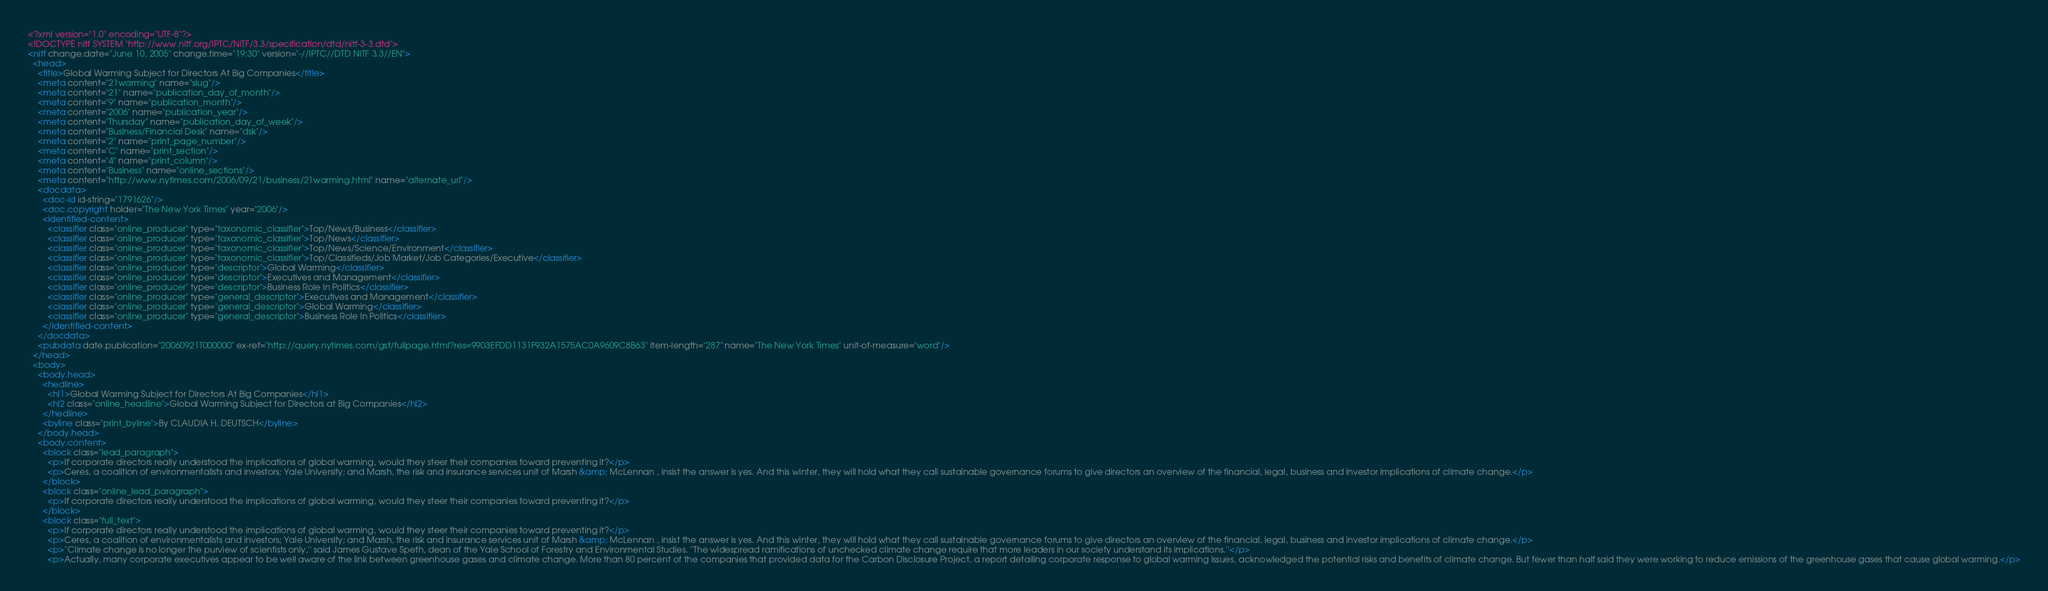<code> <loc_0><loc_0><loc_500><loc_500><_XML_><?xml version="1.0" encoding="UTF-8"?>
<!DOCTYPE nitf SYSTEM "http://www.nitf.org/IPTC/NITF/3.3/specification/dtd/nitf-3-3.dtd">
<nitf change.date="June 10, 2005" change.time="19:30" version="-//IPTC//DTD NITF 3.3//EN">
  <head>
    <title>Global Warming Subject for Directors At Big Companies</title>
    <meta content="21warming" name="slug"/>
    <meta content="21" name="publication_day_of_month"/>
    <meta content="9" name="publication_month"/>
    <meta content="2006" name="publication_year"/>
    <meta content="Thursday" name="publication_day_of_week"/>
    <meta content="Business/Financial Desk" name="dsk"/>
    <meta content="2" name="print_page_number"/>
    <meta content="C" name="print_section"/>
    <meta content="4" name="print_column"/>
    <meta content="Business" name="online_sections"/>
    <meta content="http://www.nytimes.com/2006/09/21/business/21warming.html" name="alternate_url"/>
    <docdata>
      <doc-id id-string="1791626"/>
      <doc.copyright holder="The New York Times" year="2006"/>
      <identified-content>
        <classifier class="online_producer" type="taxonomic_classifier">Top/News/Business</classifier>
        <classifier class="online_producer" type="taxonomic_classifier">Top/News</classifier>
        <classifier class="online_producer" type="taxonomic_classifier">Top/News/Science/Environment</classifier>
        <classifier class="online_producer" type="taxonomic_classifier">Top/Classifieds/Job Market/Job Categories/Executive</classifier>
        <classifier class="online_producer" type="descriptor">Global Warming</classifier>
        <classifier class="online_producer" type="descriptor">Executives and Management</classifier>
        <classifier class="online_producer" type="descriptor">Business Role In Politics</classifier>
        <classifier class="online_producer" type="general_descriptor">Executives and Management</classifier>
        <classifier class="online_producer" type="general_descriptor">Global Warming</classifier>
        <classifier class="online_producer" type="general_descriptor">Business Role In Politics</classifier>
      </identified-content>
    </docdata>
    <pubdata date.publication="20060921T000000" ex-ref="http://query.nytimes.com/gst/fullpage.html?res=9903EFDD1131F932A1575AC0A9609C8B63" item-length="287" name="The New York Times" unit-of-measure="word"/>
  </head>
  <body>
    <body.head>
      <hedline>
        <hl1>Global Warming Subject for Directors At Big Companies</hl1>
        <hl2 class="online_headline">Global Warming Subject for Directors at Big Companies</hl2>
      </hedline>
      <byline class="print_byline">By CLAUDIA H. DEUTSCH</byline>
    </body.head>
    <body.content>
      <block class="lead_paragraph">
        <p>If corporate directors really understood the implications of global warming, would they steer their companies toward preventing it?</p>
        <p>Ceres, a coalition of environmentalists and investors; Yale University; and Marsh, the risk and insurance services unit of Marsh &amp; McLennan , insist the answer is yes. And this winter, they will hold what they call sustainable governance forums to give directors an overview of the financial, legal, business and investor implications of climate change.</p>
      </block>
      <block class="online_lead_paragraph">
        <p>If corporate directors really understood the implications of global warming, would they steer their companies toward preventing it?</p>
      </block>
      <block class="full_text">
        <p>If corporate directors really understood the implications of global warming, would they steer their companies toward preventing it?</p>
        <p>Ceres, a coalition of environmentalists and investors; Yale University; and Marsh, the risk and insurance services unit of Marsh &amp; McLennan , insist the answer is yes. And this winter, they will hold what they call sustainable governance forums to give directors an overview of the financial, legal, business and investor implications of climate change.</p>
        <p>''Climate change is no longer the purview of scientists only,'' said James Gustave Speth, dean of the Yale School of Forestry and Environmental Studies. ''The widespread ramifications of unchecked climate change require that more leaders in our society understand its implications.''</p>
        <p>Actually, many corporate executives appear to be well aware of the link between greenhouse gases and climate change. More than 80 percent of the companies that provided data for the Carbon Disclosure Project, a report detailing corporate response to global warming issues, acknowledged the potential risks and benefits of climate change. But fewer than half said they were working to reduce emissions of the greenhouse gases that cause global warming.</p></code> 